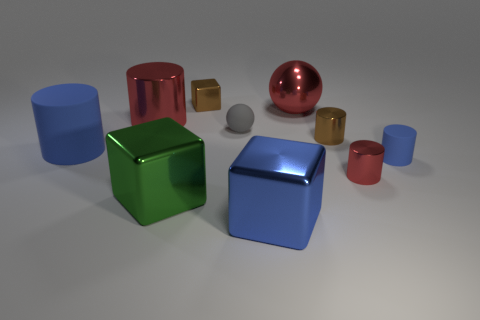Subtract all blue matte cylinders. How many cylinders are left? 3 Subtract all gray spheres. How many blue cylinders are left? 2 Subtract all blue cylinders. How many cylinders are left? 3 Subtract 2 cylinders. How many cylinders are left? 3 Subtract all cubes. How many objects are left? 7 Subtract all green cylinders. Subtract all brown blocks. How many cylinders are left? 5 Subtract 0 blue balls. How many objects are left? 10 Subtract all matte objects. Subtract all rubber cylinders. How many objects are left? 5 Add 2 large metal objects. How many large metal objects are left? 6 Add 7 tiny rubber objects. How many tiny rubber objects exist? 9 